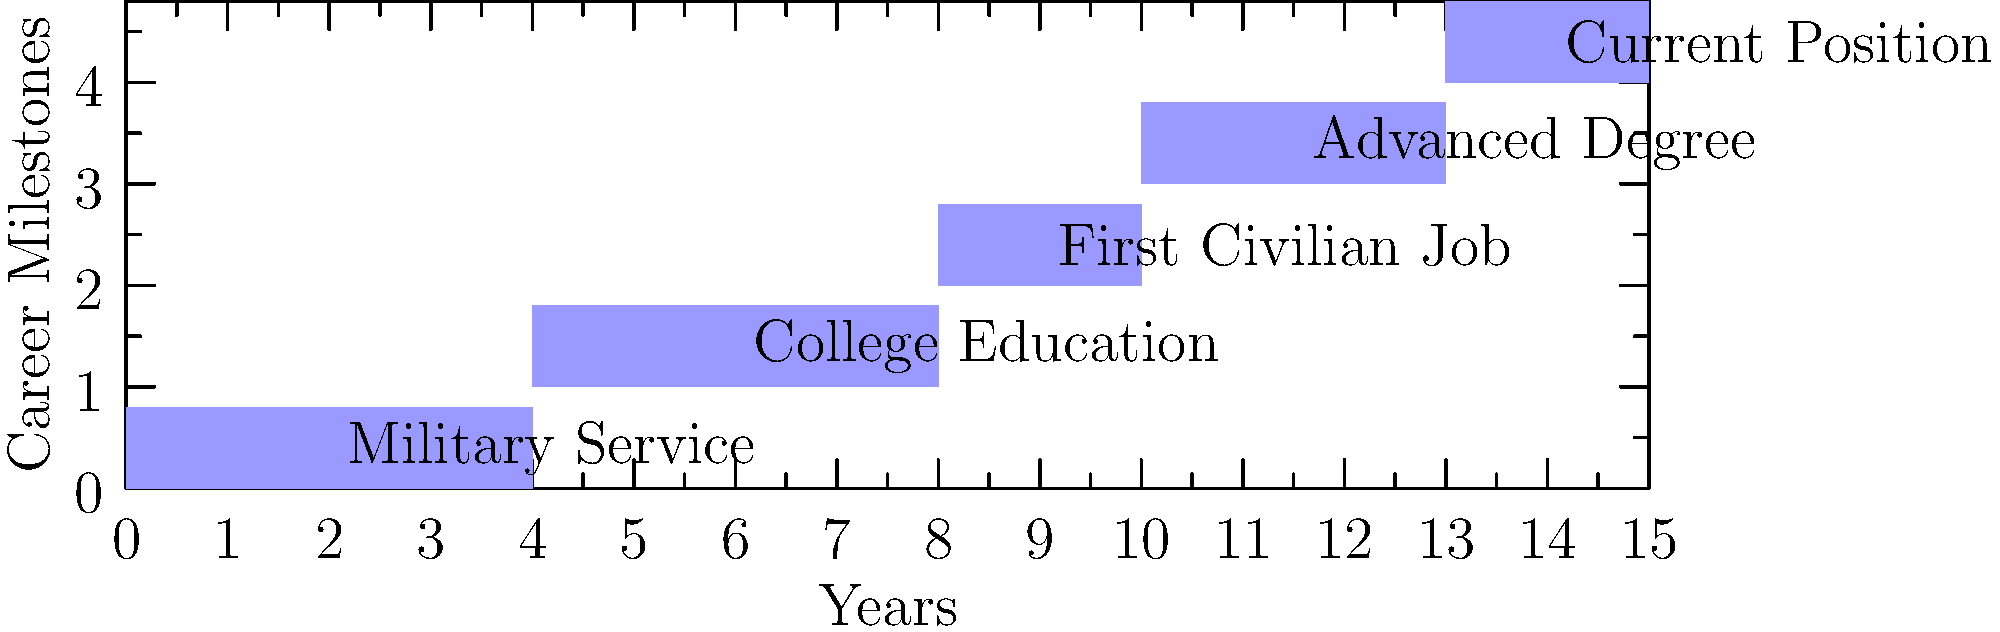As a magazine editor assigning a tech journalist to cover a veteran's career, you're presented with this timeline of the veteran's career milestones. What is the total number of years between the start of the veteran's military service and the beginning of their current position? To determine the number of years between the start of military service and the beginning of the current position, we need to follow these steps:

1. Identify the start of military service: This is at year 0 on the timeline.
2. Locate the start of the current position: This is at year 13 on the timeline.
3. Calculate the difference:
   $13 - 0 = 13$ years

The timeline shows that:
- Military Service: Years 0-4
- College Education: Years 4-8
- First Civilian Job: Years 8-10
- Advanced Degree: Years 10-13
- Current Position: Starts at Year 13

The question asks for the time between the start of military service and the start of the current position, which spans all previous career milestones.
Answer: 13 years 